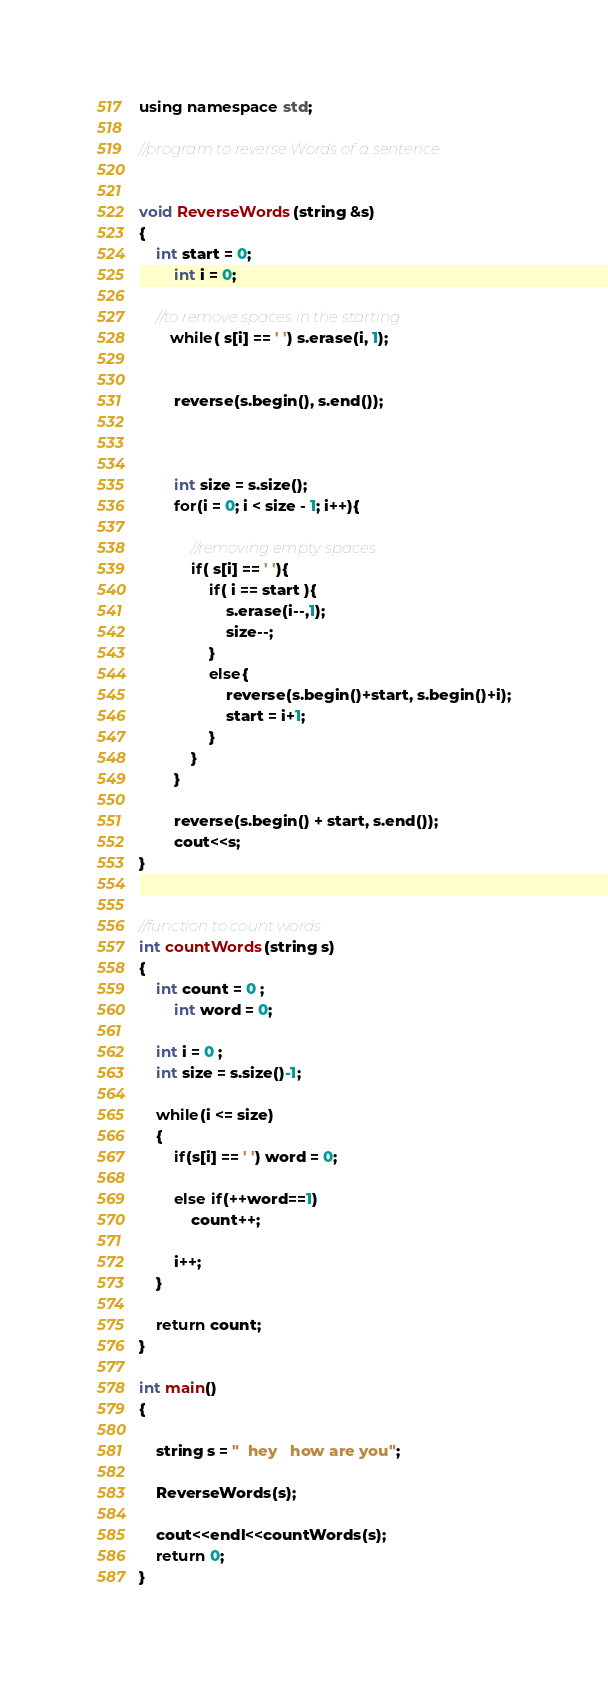<code> <loc_0><loc_0><loc_500><loc_500><_C++_>
using namespace std;

//program to reverse Words of a sentence


void ReverseWords(string &s)
{
	int start = 0;
        int i = 0;

	//to remove spaces in the starting
       while( s[i] == ' ') s.erase(i, 1);
        
        
        reverse(s.begin(), s.end());
        


        int size = s.size();
        for(i = 0; i < size - 1; i++){
        	
        	//removing empty spaces
            if( s[i] == ' '){
                if( i == start ){
                    s.erase(i--,1);
                    size--;
                }
                else{
                    reverse(s.begin()+start, s.begin()+i);
                    start = i+1;
                }
            }
        }
        
        reverse(s.begin() + start, s.end());
        cout<<s;
}	


//function to count words
int countWords(string s)
{
	int count = 0 ;
        int word = 0;
	
	int i = 0 ;
	int size = s.size()-1;
	
	while(i <= size)
	{
		if(s[i] == ' ') word = 0;
		
		else if(++word==1)
			count++;
		
		i++;
	}
	
	return count;
}

int main()
{
	
	string s = "  hey   how are you";
	
	ReverseWords(s);
	
	cout<<endl<<countWords(s);	
	return 0;
}
</code> 